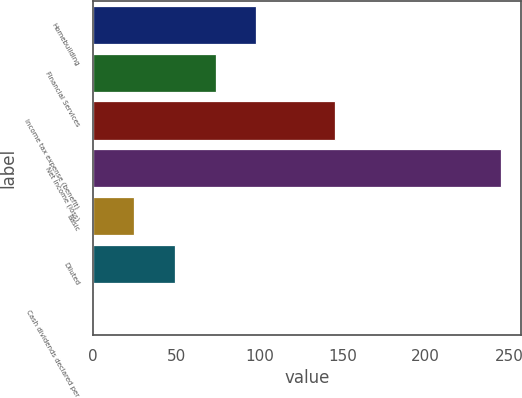Convert chart. <chart><loc_0><loc_0><loc_500><loc_500><bar_chart><fcel>Homebuilding<fcel>Financial Services<fcel>Income tax expense (benefit)<fcel>Net income (loss)<fcel>Basic<fcel>Diluted<fcel>Cash dividends declared per<nl><fcel>98.14<fcel>73.64<fcel>145.6<fcel>245.1<fcel>24.64<fcel>49.14<fcel>0.15<nl></chart> 